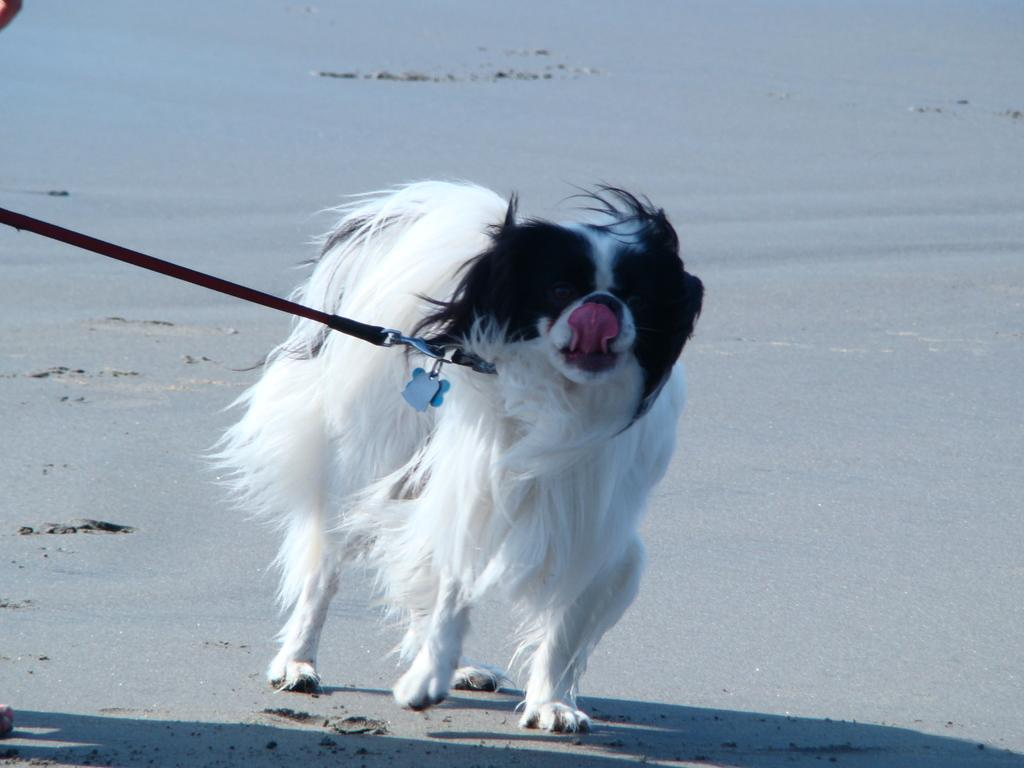What type of animal is in the image? There is a dog in the image. Can you describe the appearance of the dog? The dog is black and white. What type of terrain is visible in the background of the image? There is sand visible in the background of the image. What type of gate is present in the image? There is no gate present in the image. 